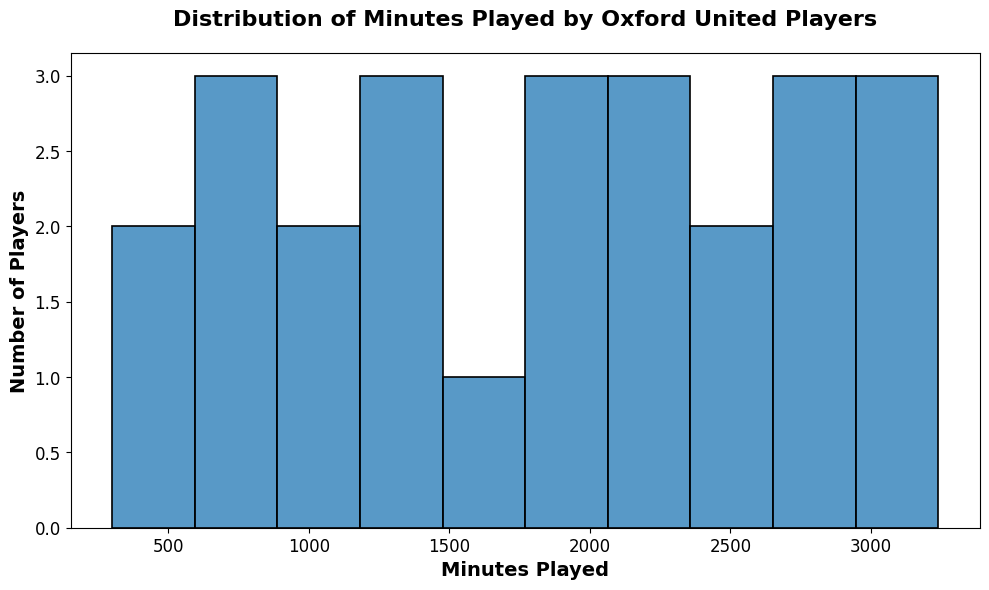Which range of minutes played had the most players? Look at the bin with the highest bars in the histogram. This represents the range where most players fall.
Answer: 2000-2400 How many players played between 1400 and 1800 minutes? Identify the bar height for the bin indicating the 1400-1800 range on the histogram, which represents the count of players.
Answer: 4 Did more players play less than 1200 minutes or more than 2400 minutes? Compare the sum of players represented by the heights of the bars for the ranges less than 1200 and greater than 2400 minutes.
Answer: Less than 1200 minutes What’s the approximate median value of minutes played? To find the median, locate the middle value of the sorted list of minutes played. In a histogram, this typically falls in the middle bin range where the cumulative count reaches half.
Answer: 1850-2100 How many bins are there in the histogram? Count the number of vertical bars (bins) present in the histogram.
Answer: 10 Which bin range had the fewest players? Find the shortest bar in the histogram and its corresponding range.
Answer: 2400-2800 What's the total number of players in the histogram? Sum the heights of all the bars to get the total count of players.
Answer: 25 Compare the number of players who played between 0-600 minutes to those who played between 3000-3600 minutes? Identify and compare the heights of the bars corresponding to these ranges.
Answer: 3 vs 2 Is there a bin where exactly three players fall? Look for a bar with a height equal to three in the histogram.
Answer: Yes, 1200-1600 What is the range of the bin with the second highest number of players? Identify the second tallest bar in the histogram and note its range.
Answer: 1600-2000 